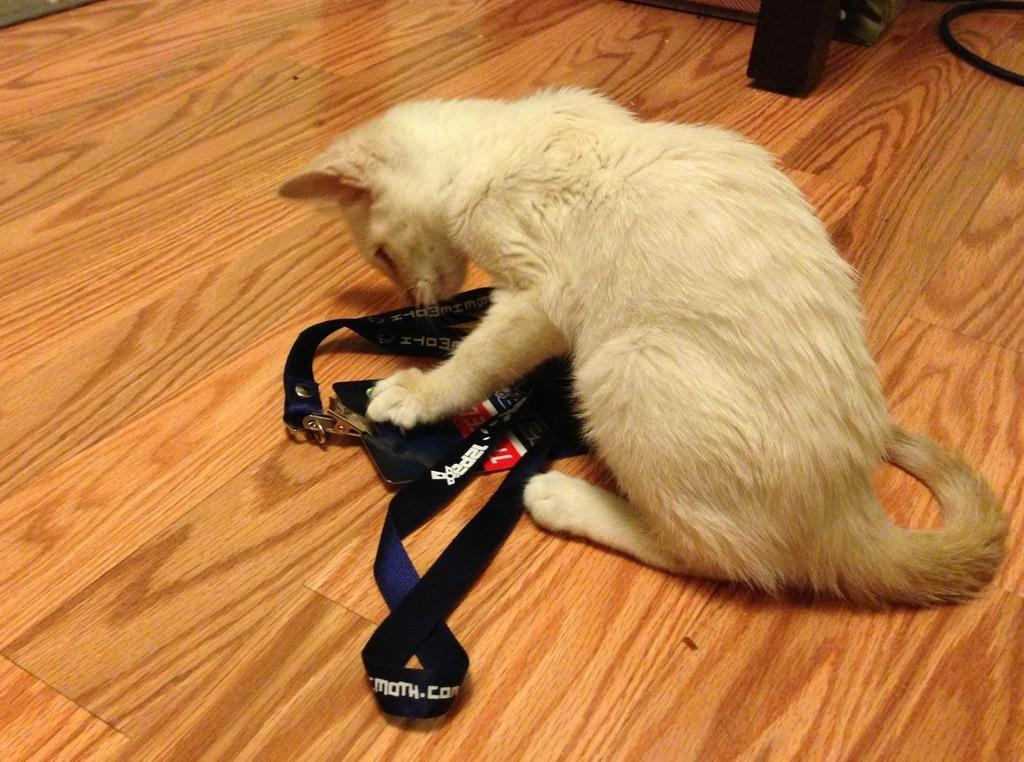What animal can be seen in the image? There is a cat in the image. What is the cat holding in its mouth? The cat is holding a strap. What type of flooring is visible in the image? The wooden floor is visible in the image. What can be seen in the top right corner of the image? There is a cable and a wooden stand in the top right corner of the image. What color is the silver object that the cat is talking to in the image? There is no silver object or talking cat present in the image. 